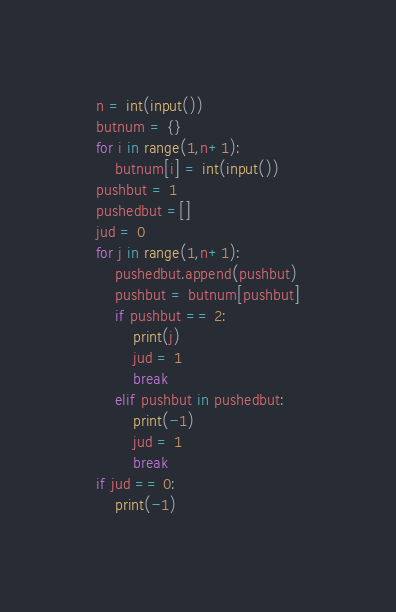<code> <loc_0><loc_0><loc_500><loc_500><_Python_>n = int(input())
butnum = {}
for i in range(1,n+1):
    butnum[i] = int(input())
pushbut = 1
pushedbut =[]
jud = 0
for j in range(1,n+1):
    pushedbut.append(pushbut)
    pushbut = butnum[pushbut]
    if pushbut == 2:
        print(j)
        jud = 1
        break
    elif pushbut in pushedbut:
        print(-1)
        jud = 1
        break
if jud == 0:
    print(-1)</code> 